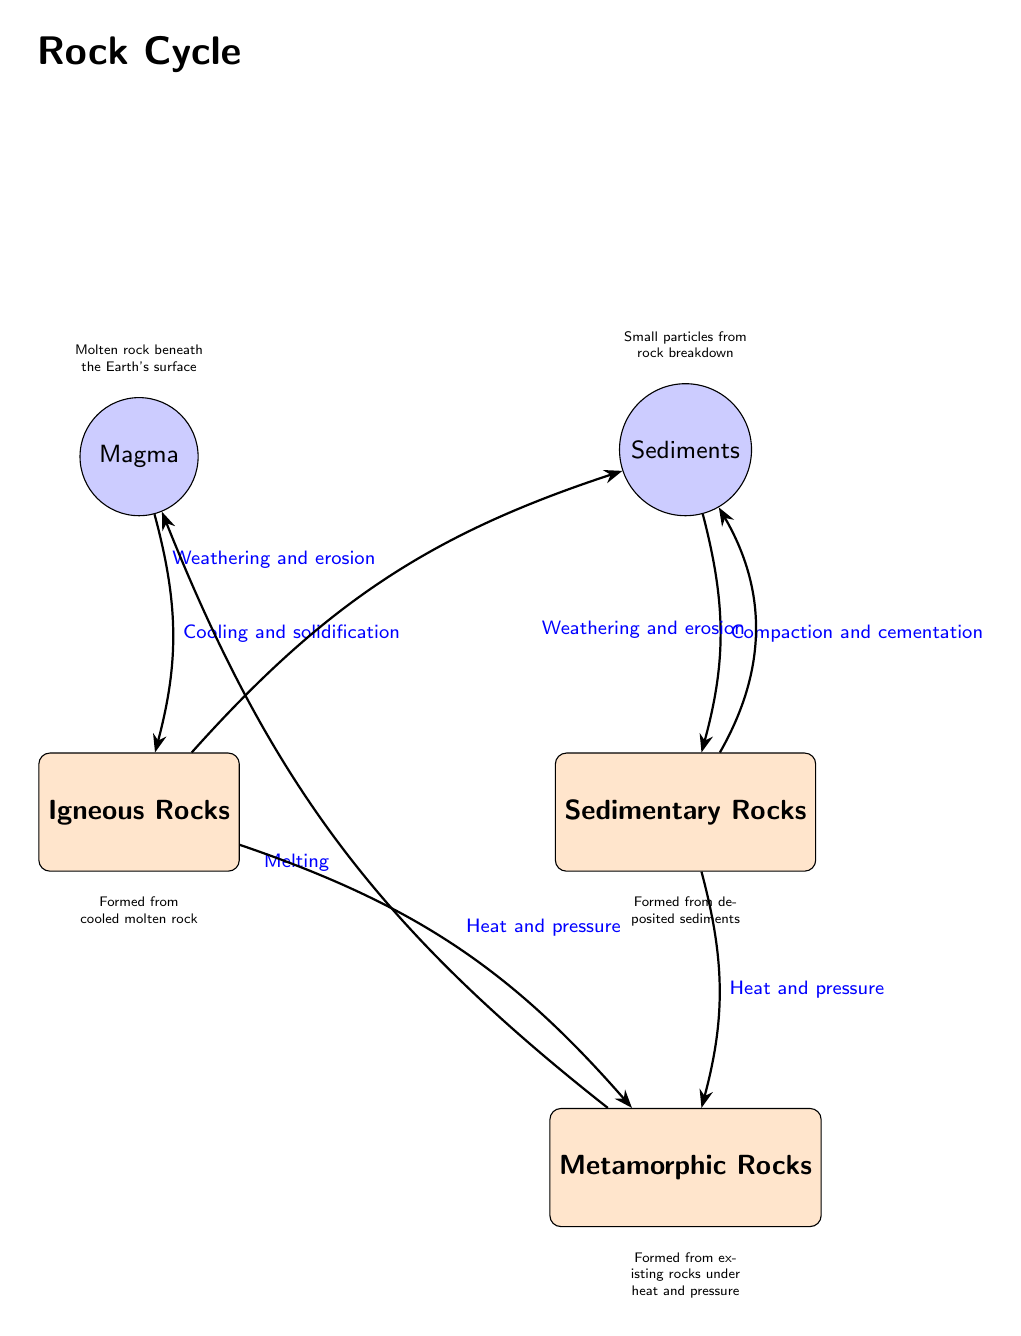What's at the top of the diagram? The top node of the diagram is labeled "Magma," representing molten rock beneath the Earth's surface.
Answer: Magma How many main rock types are represented in the diagram? The diagram shows three main rock types: Igneous, Sedimentary, and Metamorphic.
Answer: 3 What process transforms magma into igneous rocks? The process labeled on the arrow from Magma to Igneous Rocks is "Cooling and solidification," indicating how magma becomes igneous rocks.
Answer: Cooling and solidification What process causes sedimentary rocks to transform into metamorphic rocks? The arrow from Sedimentary Rocks to Metamorphic Rocks is labeled "Heat and pressure," marking the transformation process.
Answer: Heat and pressure What type of rocks are formed from small particles due to weathering and erosion? The node labeled Sedimentary Rocks is linked to the idea of small particles from rock breakdown, indicating its formation from sediments.
Answer: Sedimentary Rocks Which rock type can become magma again? The diagram shows that both Metamorphic and Igneous Rocks can convert back into Magma; however, based on the flows shown, only the Metamorphic Rocks are directly indicated to turn back into magma via the process of melting.
Answer: Metamorphic Rocks What happens to igneous rocks when they undergo weathering and erosion? The arrow points from Igneous Rocks to Sediments through the process labeled "Weathering and erosion," indicating this transformation step.
Answer: Sediments What is formed from deposited sediments? The node titled Sedimentary Rocks describes rocks that are formed from the accumulation and compaction of sediments.
Answer: Sedimentary Rocks 